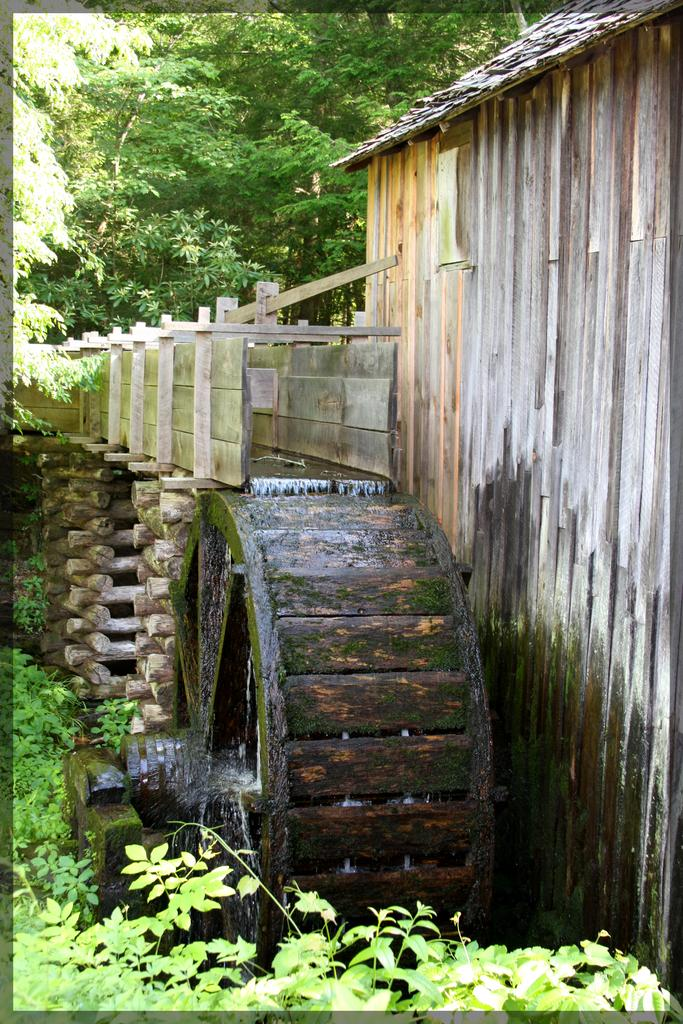What type of vegetation can be seen in the foreground of the image? There is greenery in the foreground of the image, both at the bottom and top. What material is the wall in the middle of the image made of? The wall in the middle of the image is made of wood. What is happening to the wheel in the image? Water is flowing onto a wheel in the image. How many rabbits are hopping around the wooden wall in the image? There are no rabbits present in the image. What type of bulb is illuminating the greenery in the foreground of the image? There is no bulb present in the image; the greenery is illuminated by natural light. 